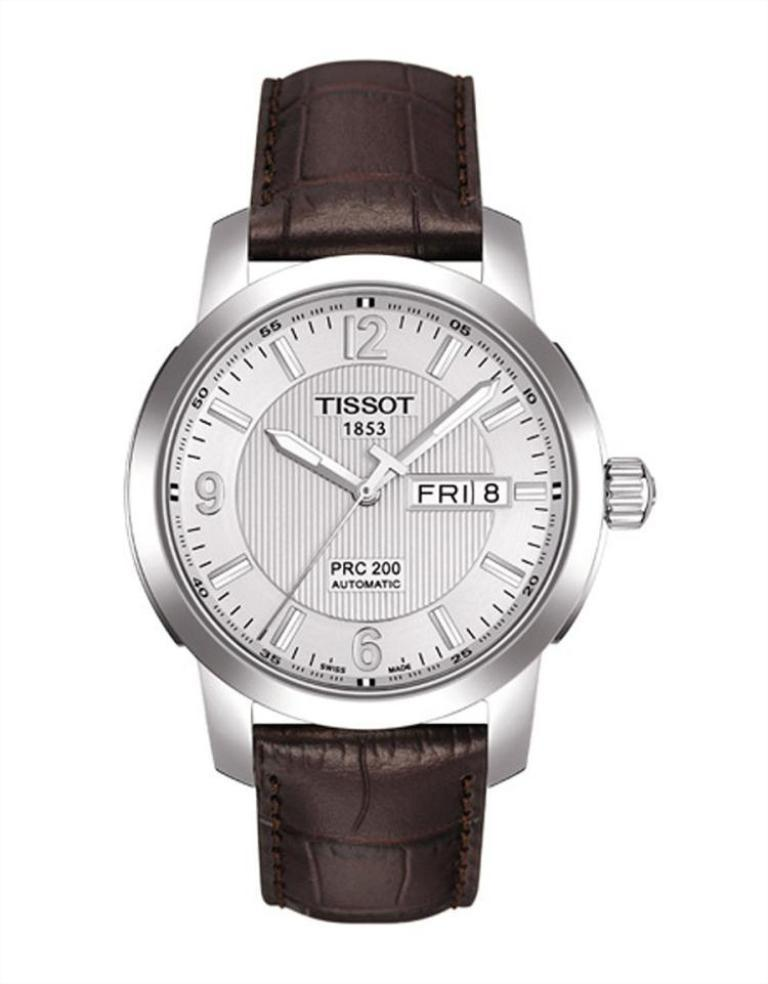<image>
Present a compact description of the photo's key features. A Tissot watch says it is a PRC 200 automatic. 